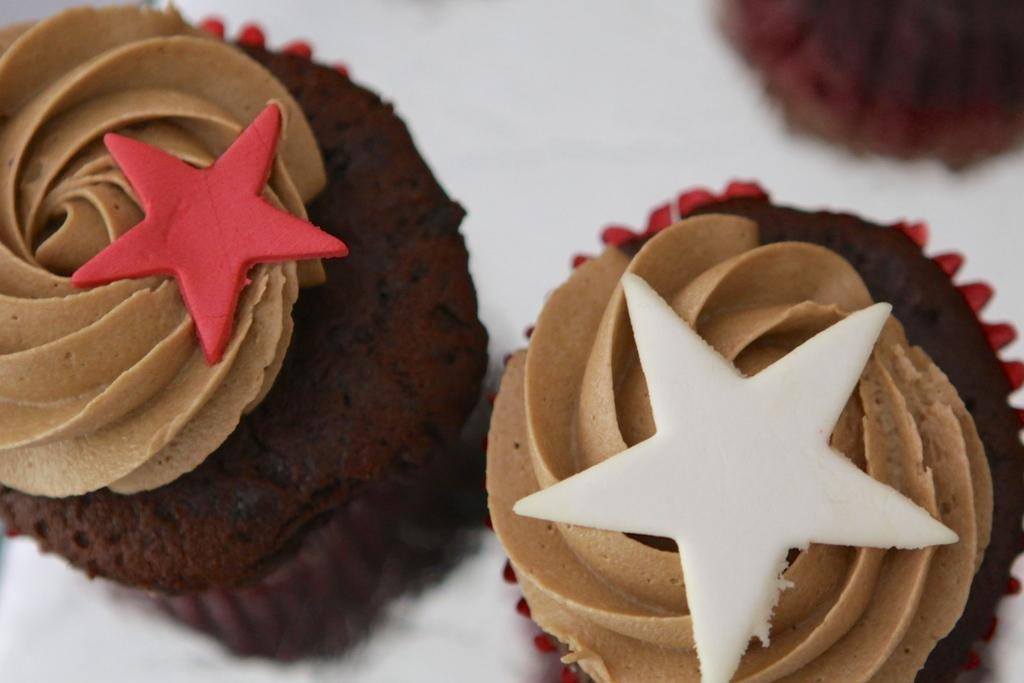What type of dessert can be seen on the white surface in the image? There are cupcakes on a white surface in the image. What is the appearance of the cupcakes? The cupcakes have cream on them. Can you describe the design of the cream on the cupcakes? The cream on the cupcakes has a star shape. Are there any snails crawling on the cupcakes in the image? No, there are no snails present in the image. What type of party is being depicted in the image? The image does not depict a party; it only shows cupcakes with star-shaped cream on a white surface. 